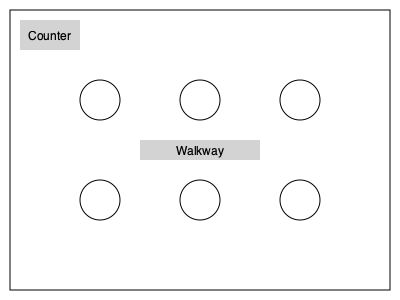Given the floor plan of your small café, which shows 6 circular tables and a counter, what is the maximum number of customers that can be seated if you want to maintain a minimum distance of 1.5 meters between the centers of occupied tables for social distancing? To solve this problem, we need to follow these steps:

1. Analyze the floor plan:
   - There are 6 circular tables arranged in a 3x2 grid.
   - The counter and walkway are not suitable for seating.

2. Consider the social distancing requirement:
   - We need to maintain a minimum distance of 1.5 meters between the centers of occupied tables.

3. Determine the maximum number of tables that can be occupied while meeting the distancing requirement:
   - In a 3x2 grid, the tables that are diagonally opposite each other will always be more than 1.5 meters apart.
   - We can occupy a maximum of 3 tables without violating the distancing rule.

4. Calculate the maximum number of customers:
   - Assuming each table can seat 2-4 customers (typical for small café tables), let's use an average of 3 customers per table.
   - Maximum number of customers = Number of occupied tables × Average customers per table
   - Maximum number of customers = $3 \times 3 = 9$

Therefore, the maximum number of customers that can be seated while maintaining the required social distance is 9.
Answer: 9 customers 